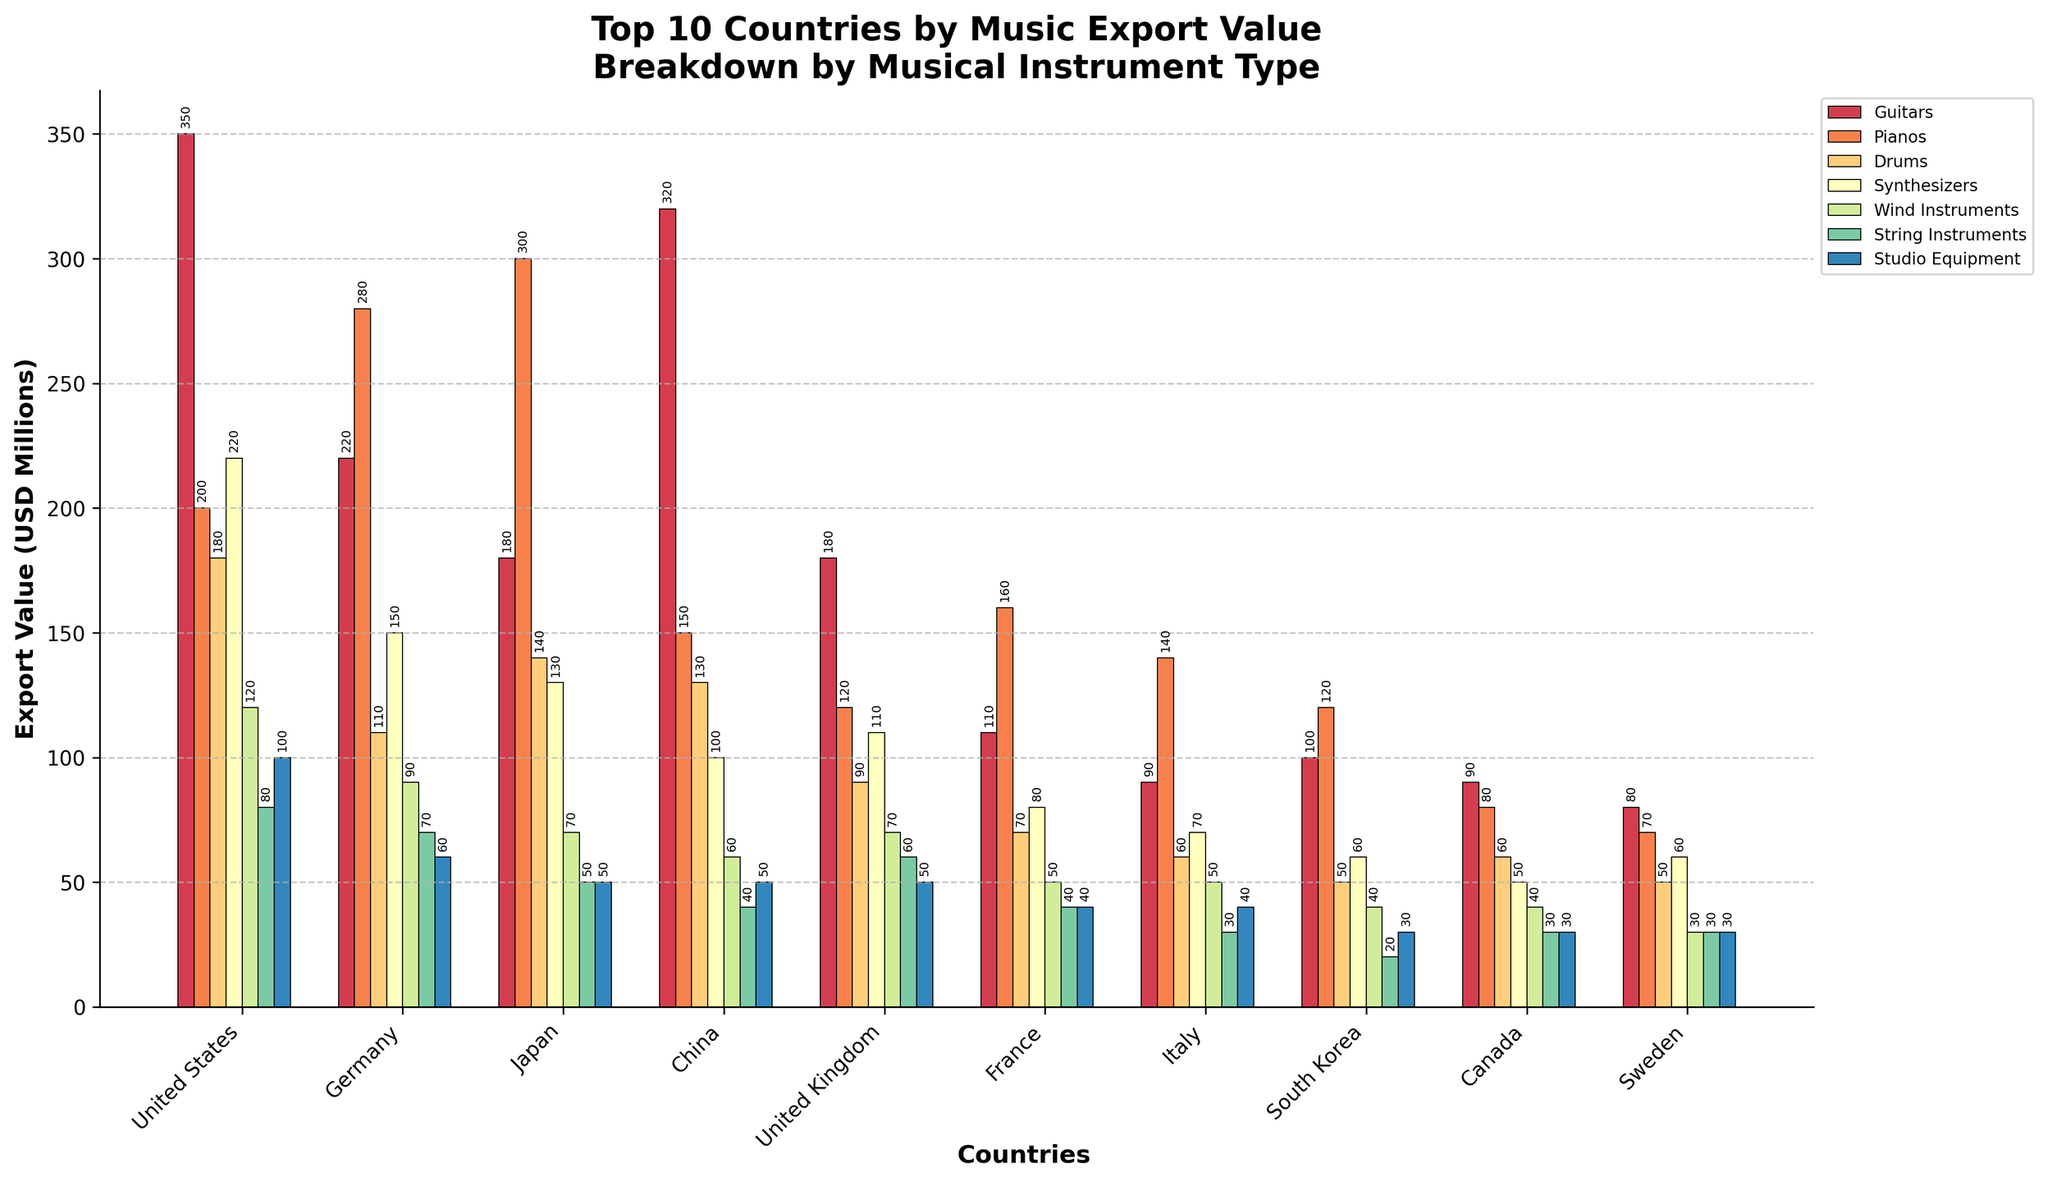Which country has the highest total export value of music instruments? By observing the tallest bar stacks in the figure, it is clear that the United States has the highest total export value of music instruments compared to other countries.
Answer: United States Which type of musical instrument has the highest export value in Japan? By looking at the bar corresponding to Japan, the highest segment (tallest bar for Japan) is for Pianos.
Answer: Pianos What is the combined export value for Guitars and Studio Equipment in China? The height of the bar for Guitars in China is 320, and for Studio Equipment, it is 50. Summing these values gives 320 + 50 = 370.
Answer: 370 Which country exports more Pianos, Germany or the United States? Comparing the heights of the Piano bars for Germany and the United States, it's evident that Germany's Piano bar is higher.
Answer: Germany How does the export value of Drums in the United Kingdom compare to that in Canada? The bar for Drums in the United Kingdom is slightly taller than the one in Canada, indicating a higher export value.
Answer: United Kingdom What is the total export value of String Instruments for Italy and France combined? Italy's export value for String Instruments is 30, and France's is 40. Adding these gives 30 + 40 = 70.
Answer: 70 Which musical instrument type has the smallest export value for South Korea? Observing the smallest bar segment for South Korea, the String Instruments have the smallest export value.
Answer: String Instruments Among the top 10 countries, which one has the lowest total export value of music instruments? The shortest bar stack corresponds to Sweden, indicating it has the lowest total export value of music instruments.
Answer: Sweden What is the difference in Guitar export values between the United States and Germany? The bar for Guitars indicates 350 in the United States and 220 in Germany. The difference is 350 - 220 = 130.
Answer: 130 How many countries have a higher export value for Synthesizers than for Wind Instruments? By counting the countries where the Synthesizers bar is taller than the Wind Instruments bar, we find the United States, Germany, Japan, China, and the United Kingdom (total of 5).
Answer: 5 